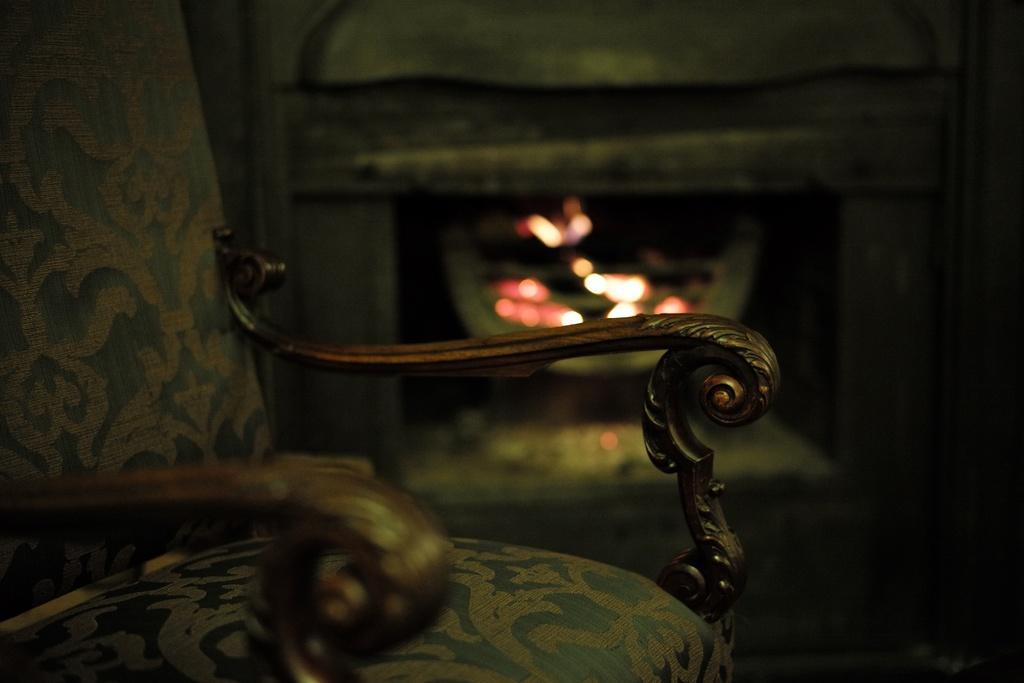Describe this image in one or two sentences. On the left side it is a chair and in the middle it's a fire place. 